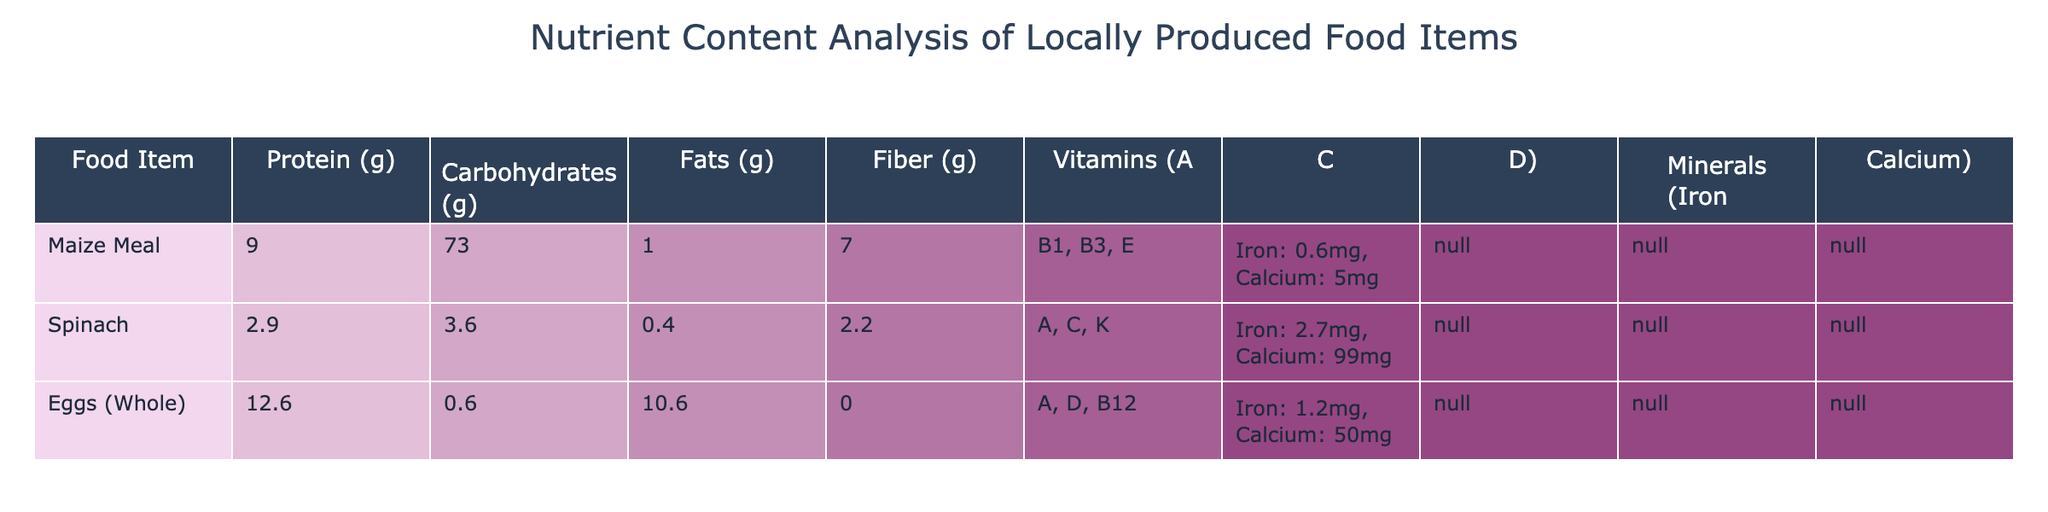What food item has the highest protein content? By looking at the protein column in the table, we see that Eggs (Whole) has the highest value at 12.6 grams compared to Maize Meal (9.0 g) and Spinach (2.9 g).
Answer: Eggs (Whole) Which food item contains the lowest amount of carbohydrates? By examining the carbohydrates column, Spinach has the lowest value at 3.6 grams, whereas Maize Meal has 73.0 grams and Eggs (Whole) has 0.6 grams.
Answer: Eggs (Whole) How much fiber is present in Maize Meal? The fiber content for Maize Meal is clearly listed in the table under the Fiber column, which shows 7.0 grams.
Answer: 7.0 grams Does Spinach contain more Iron than Eggs (Whole)? Looking at the Iron content, Spinach has 2.7 mg while Eggs (Whole) has 1.2 mg, so Spinach does contain more Iron than Eggs.
Answer: Yes What is the total fat content for all three food items combined? Adding the fat content from each food item: Maize Meal (1.0 g) + Spinach (0.4 g) + Eggs (Whole) (10.6 g) gives a total of 1.0 + 0.4 + 10.6 = 12.0 grams.
Answer: 12.0 grams Which food item has the highest combined content of Iron and Calcium? For Maize Meal, Iron is 0.6 mg and Calcium is 5 mg (total 5.6); for Spinach, Iron is 2.7 mg and Calcium is 99 mg (total 101.7); for Eggs (Whole), Iron is 1.2 mg and Calcium is 50 mg (total 51.2). Therefore, Spinach has the highest combined content of Iron and Calcium.
Answer: Spinach What percentage of the total carbohydrates does Maize Meal represent? Total carbohydrates are 73.0 (Maize Meal) + 3.6 (Spinach) + 0.6 (Eggs) = 77.2 grams. The percentage is (73.0 / 77.2) * 100 = 94.6%.
Answer: 94.6% Does Eggs (Whole) provide any fiber? Looking at the Fiber column for Eggs (Whole), it shows 0.0 grams, indicating that it does not provide any fiber.
Answer: No What is the average protein content of the three food items? The average protein content can be calculated as the total protein content (9.0 + 2.9 + 12.6 = 24.5 grams) divided by the number of food items (3), which equals 24.5 / 3 = 8.17 grams.
Answer: 8.17 grams 